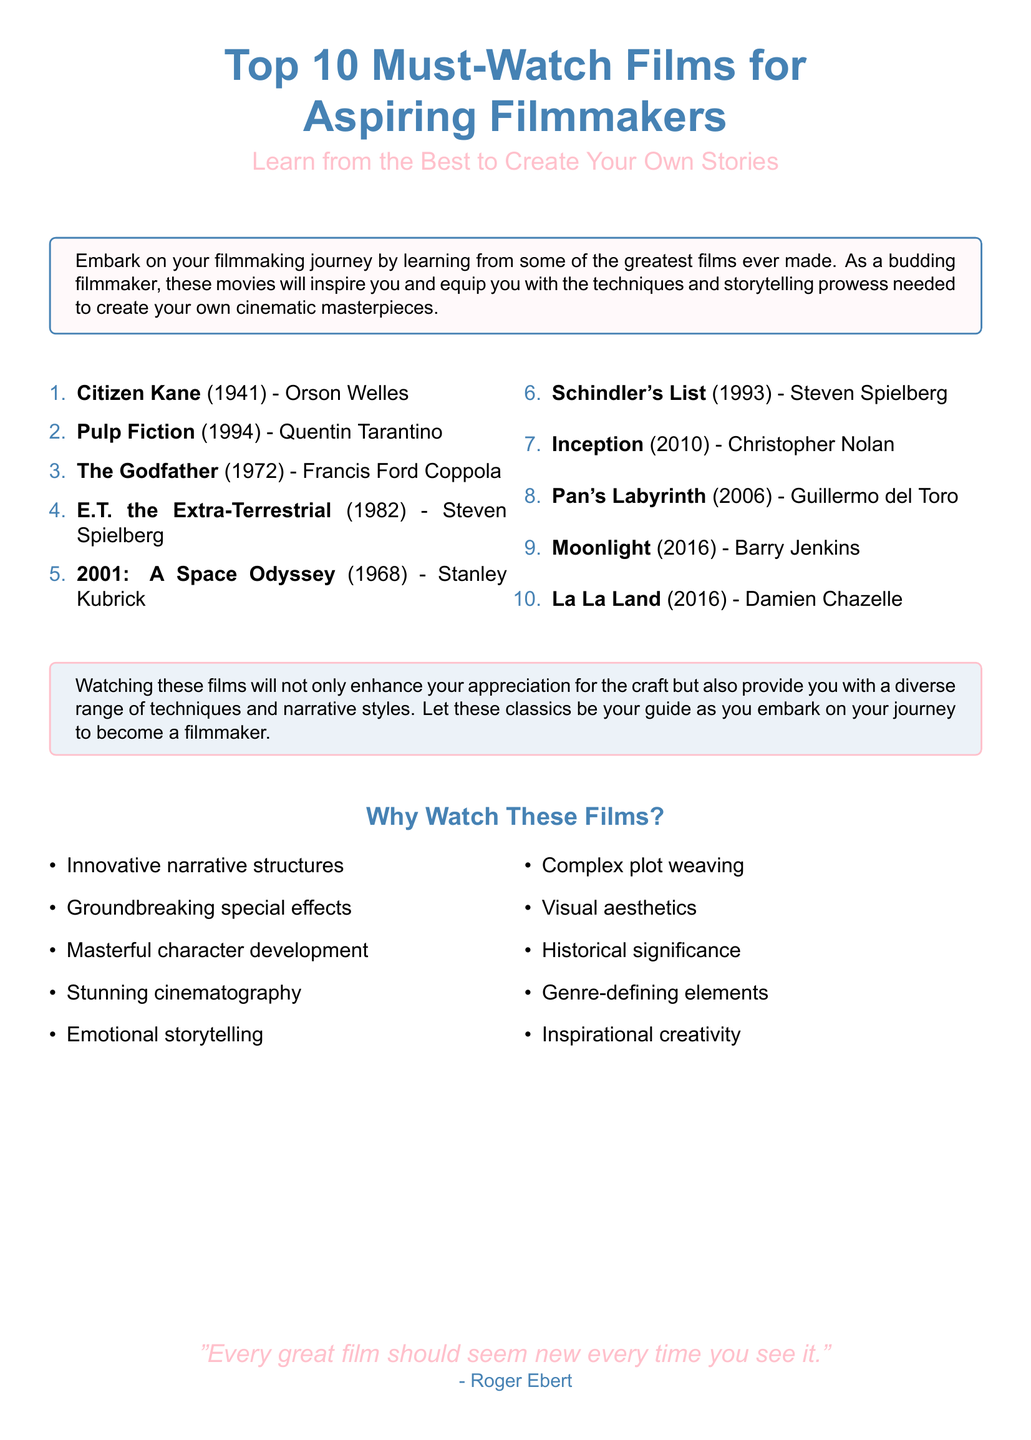What is the first film listed? The first film listed in the document under the must-watch films is "Citizen Kane."
Answer: Citizen Kane How many films are recommended in total? The document lists a total of ten films for aspiring filmmakers.
Answer: 10 Who directed "Pulp Fiction"? The document indicates that "Pulp Fiction" was directed by Quentin Tarantino.
Answer: Quentin Tarantino What year was "2001: A Space Odyssey" released? According to the document, "2001: A Space Odyssey" was released in the year 1968.
Answer: 1968 Which film is listed under the year 2016? The document names "Moonlight" and "La La Land" as films released in 2016.
Answer: Moonlight, La La Land What color is the box that contains the films? The color of the box containing the film list is pink with a light tint.
Answer: Pink What quote is featured at the bottom of the flyer? The document features a quote by Roger Ebert stating, "Every great film should seem new every time you see it."
Answer: "Every great film should seem new every time you see it." What are two elements mentioned in the reasons to watch these films? The document lists several reasons, including "Innovative narrative structures" and "Emotional storytelling."
Answer: Innovative narrative structures, Emotional storytelling Which director is associated with "Schindler's List"? According to the document, "Schindler's List" was directed by Steven Spielberg.
Answer: Steven Spielberg 